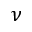Convert formula to latex. <formula><loc_0><loc_0><loc_500><loc_500>\nu</formula> 